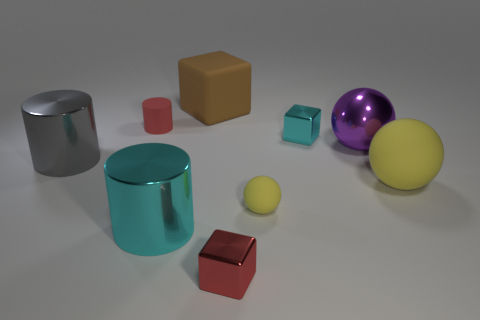What is the size of the block that is the same color as the matte cylinder? The block that shares the same color as the matte cylinder is relatively small in comparison to other objects in the scene. It's a small, cube-shaped object with a matte finish, much like the cylinder's texture, but unlike the cylinder, it has sharp edges and defined faces. 